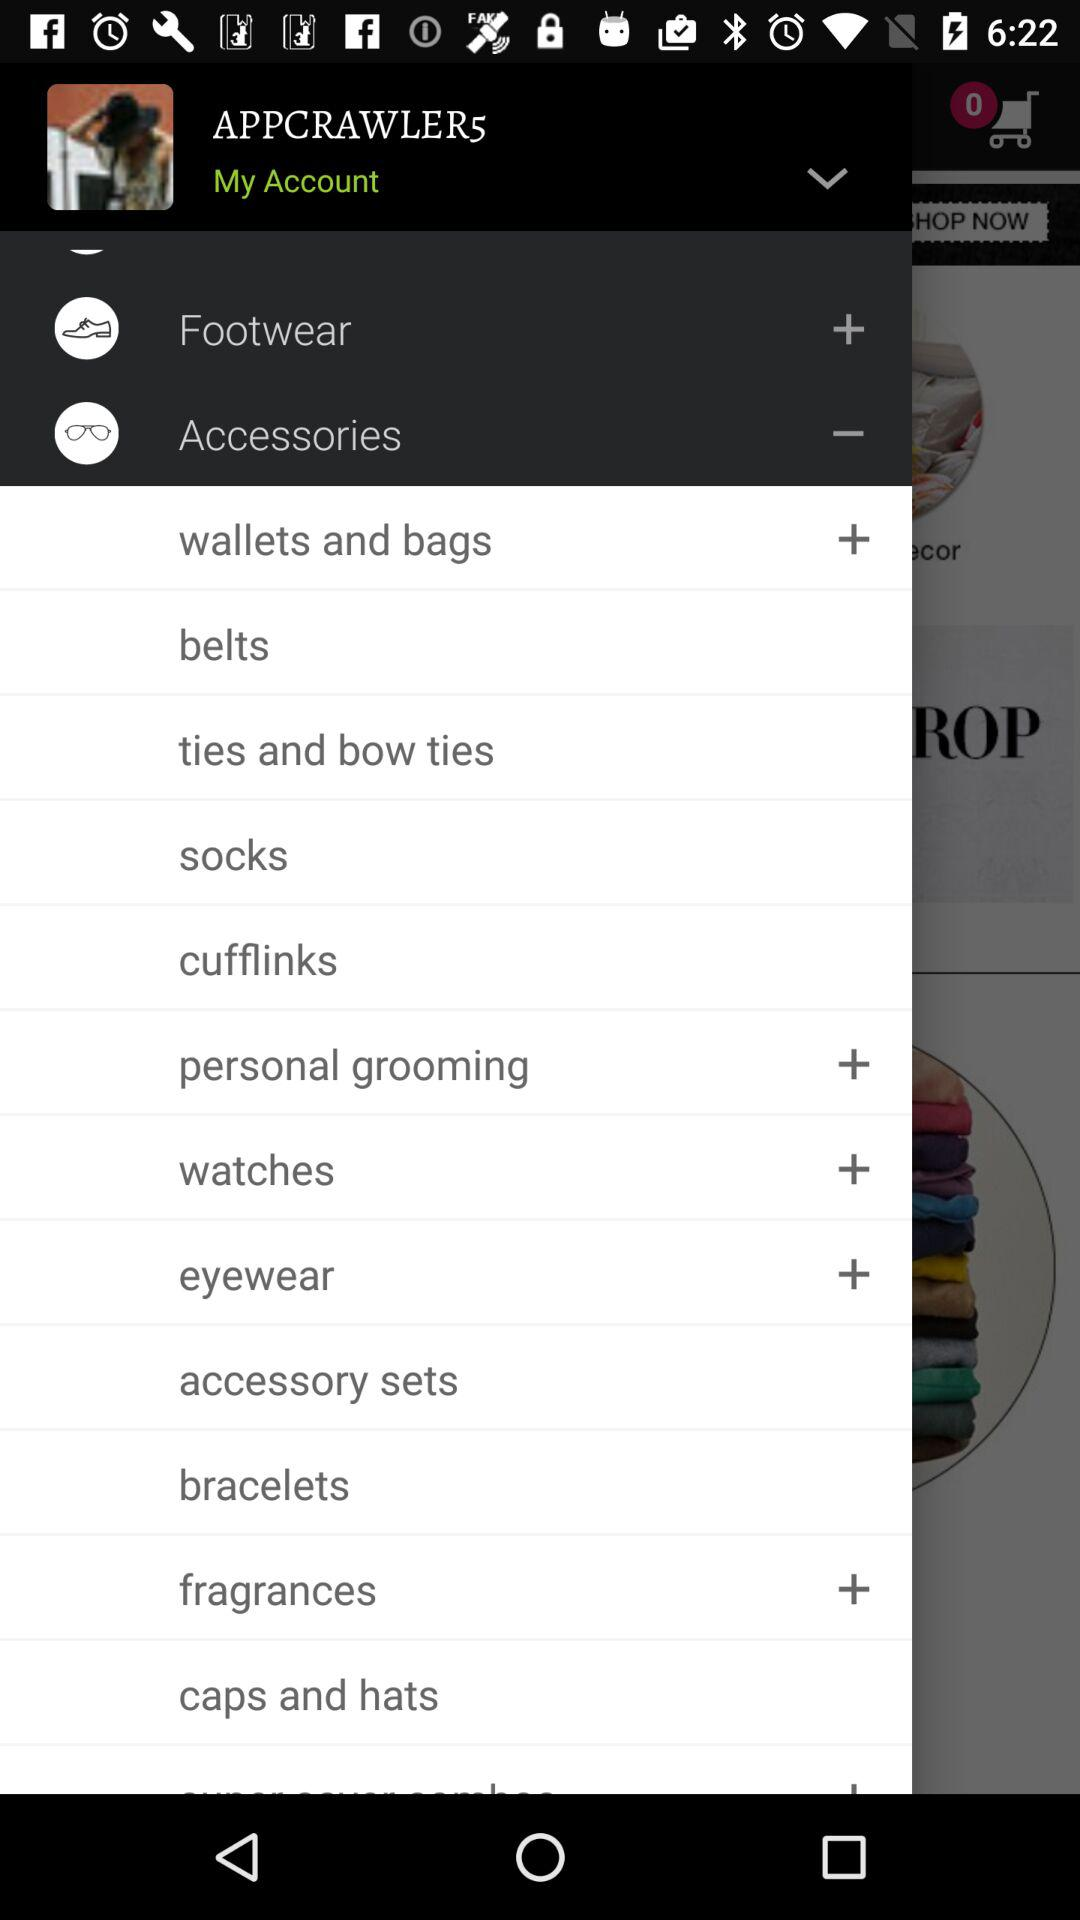What is the username? The username is "APPCRAWLER5". 